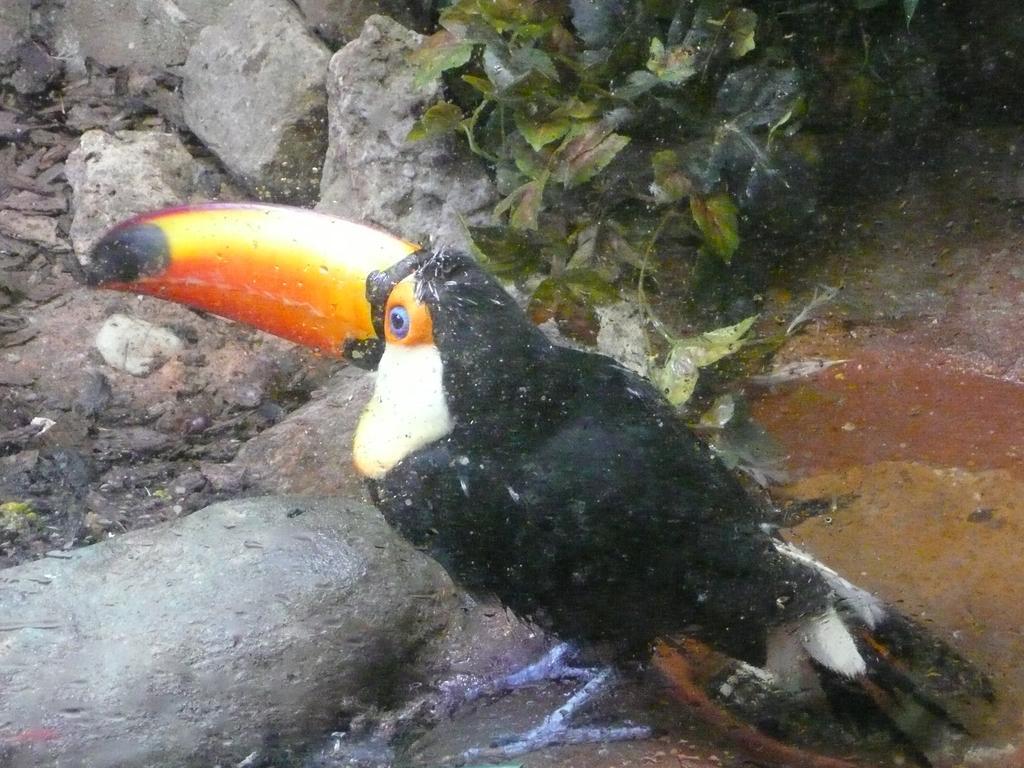Can you describe this image briefly? In this picture, we can see a bird on the ground, we can see stones, plants, and some objects on the ground. 